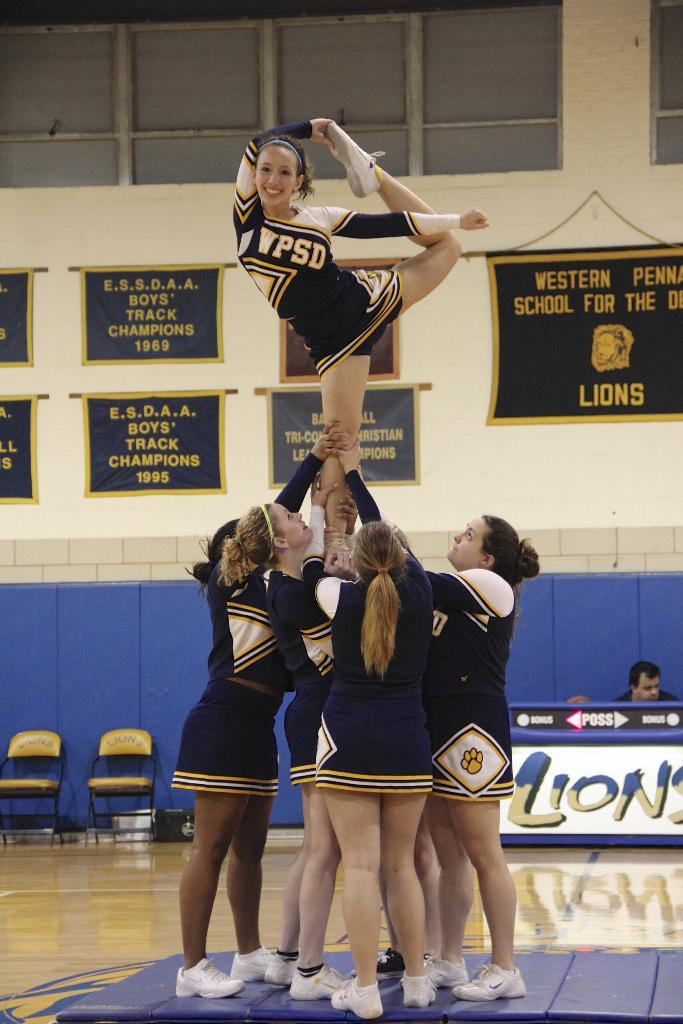<image>
Describe the image concisely. The cheer leading squad pictured are from WPSD. 